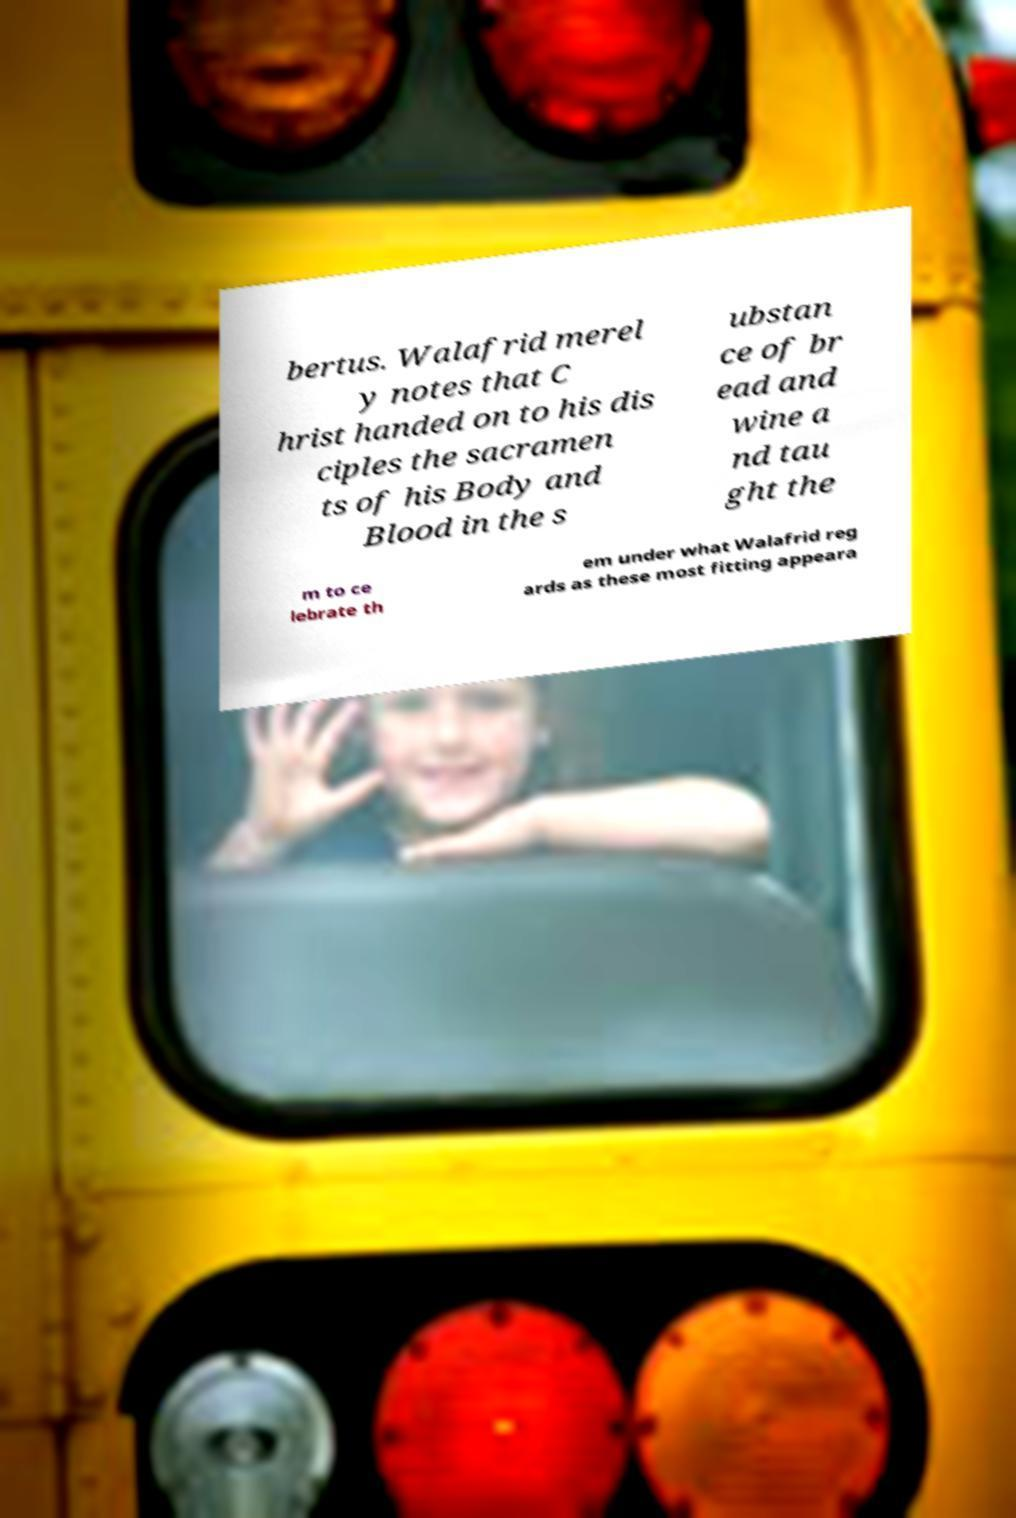Please read and relay the text visible in this image. What does it say? bertus. Walafrid merel y notes that C hrist handed on to his dis ciples the sacramen ts of his Body and Blood in the s ubstan ce of br ead and wine a nd tau ght the m to ce lebrate th em under what Walafrid reg ards as these most fitting appeara 